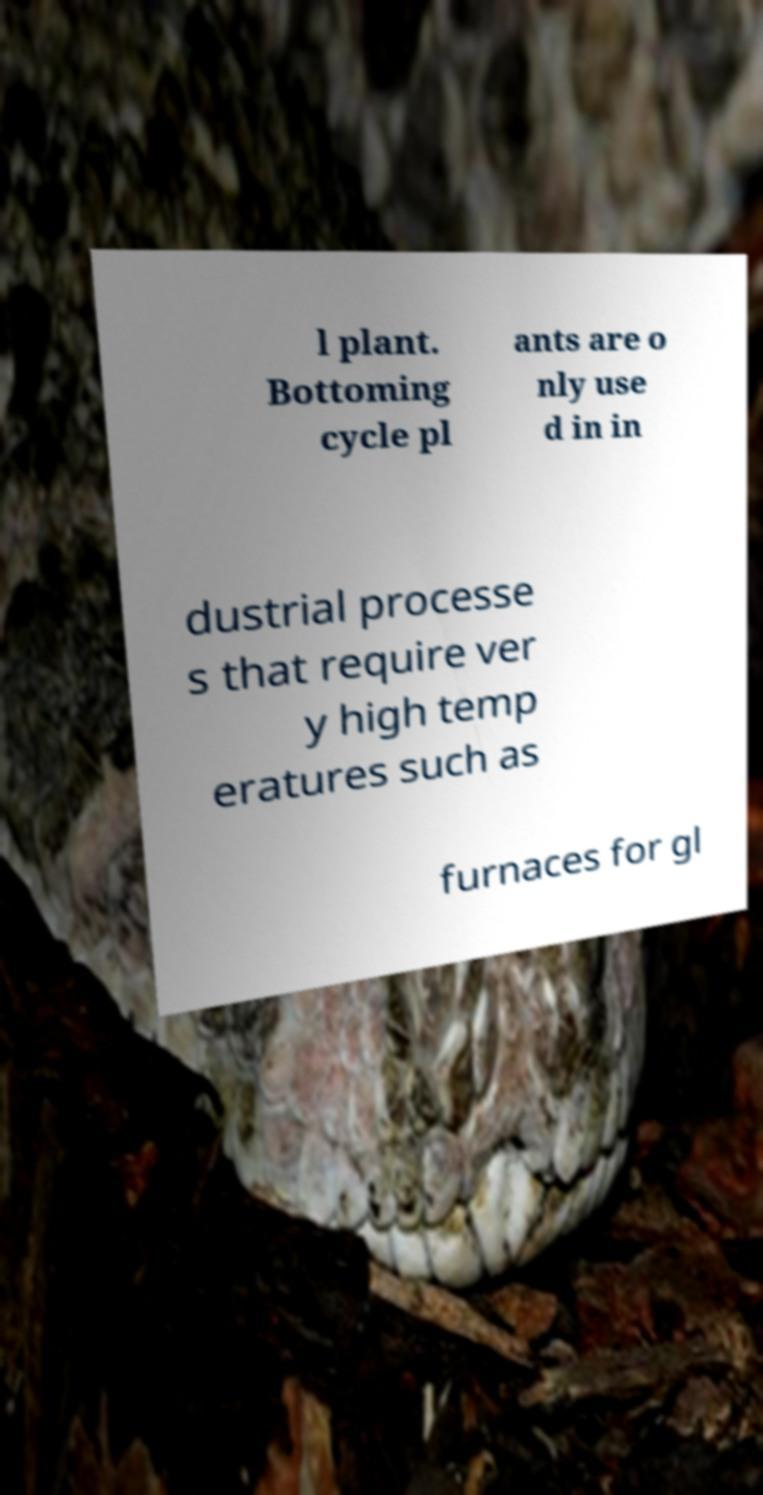Could you extract and type out the text from this image? l plant. Bottoming cycle pl ants are o nly use d in in dustrial processe s that require ver y high temp eratures such as furnaces for gl 